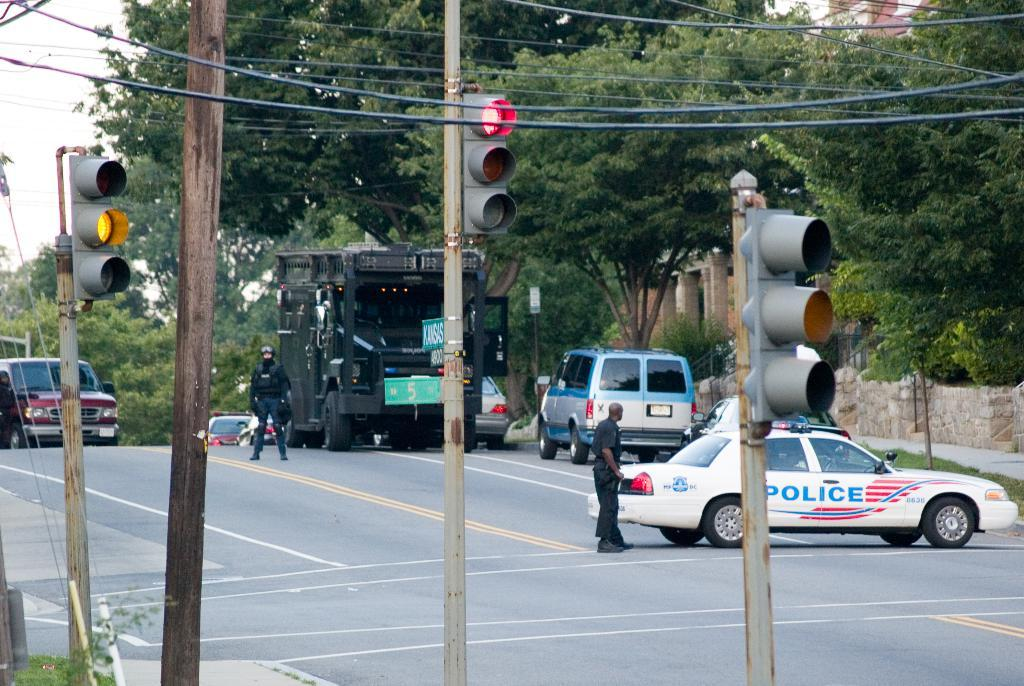<image>
Render a clear and concise summary of the photo. An intersection with a police car and SWAT vehicle. 